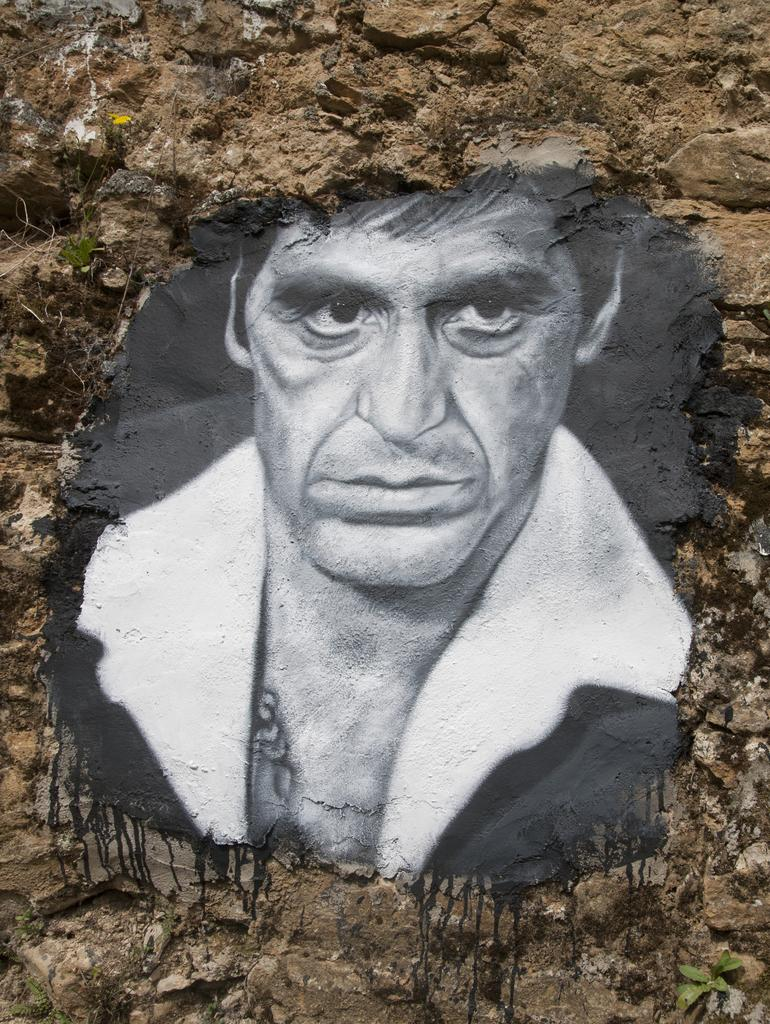What is the main subject of the image? There is a painting in the image. What is depicted in the painting? The painting depicts a person. What is the setting or environment in which the person is located? The person is on a rocky surface. What type of brick is being used to create the coat worn by the person in the painting? There is no mention of a coat or brick in the image or the provided facts. The painting only depicts a person on a rocky surface. 